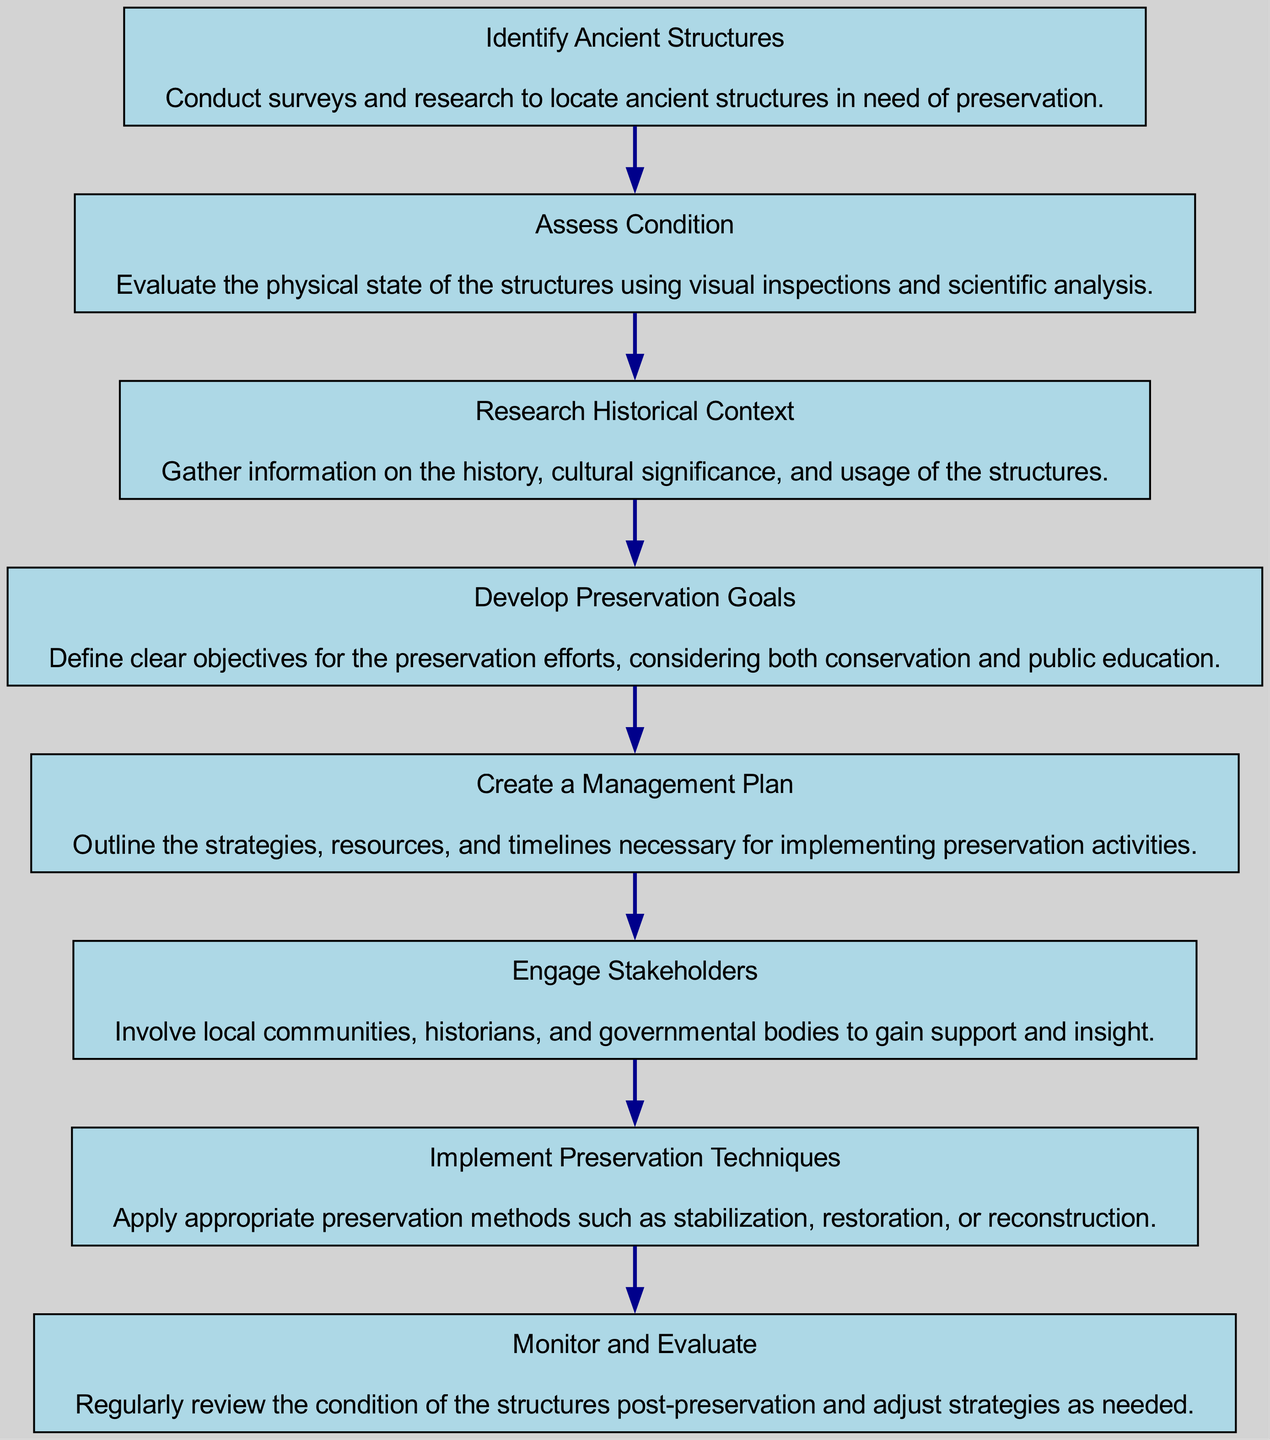What is the first step in the preservation plan? The first step in the diagram is labeled "Identify Ancient Structures." This is the initial node and does not have a preceding node.
Answer: Identify Ancient Structures How many total steps are involved in the preservation plan? By counting each node in the diagram, there are eight distinct steps outlined for the preservation plan.
Answer: 8 What step comes after "Research Historical Context"? In the sequence of the flow chart, after "Research Historical Context" is the step "Develop Preservation Goals." This can be seen by following the arrows from one step to the next.
Answer: Develop Preservation Goals Which step involves community involvement? The step "Engage Stakeholders" explicitly mentions the involvement of local communities, historians, and governmental bodies to gain support and insights.
Answer: Engage Stakeholders What is the final step in the preservation process? The last step in the flow chart is "Monitor and Evaluate," which indicates it is the final action taken post-preservation.
Answer: Monitor and Evaluate How many relationships (edges) are shown in the diagram? Each step in the diagram connects to the next one with a directed edge. Since there are eight steps, there are seven edges connecting them.
Answer: 7 What type of evaluation happens in the final step? The final step titled "Monitor and Evaluate" suggests that a review of the condition of the structures occurs after preservation efforts, indicating an ongoing assessment process.
Answer: Review What is the purpose of the "Develop Preservation Goals" step? This step is focused on defining clear objectives for preservation efforts, which includes aspects of conservation and public education, as stated in its description.
Answer: Define clear objectives 